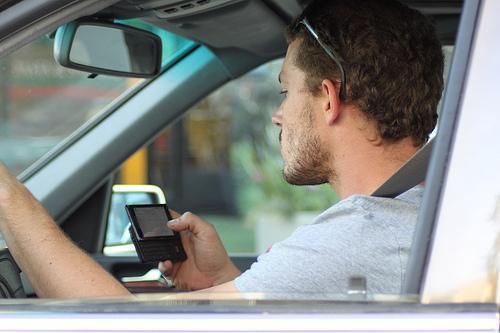How many men are there?
Give a very brief answer. 1. How many hands does the man have on the wheel?
Give a very brief answer. 1. How many mirrors are in the picture?
Give a very brief answer. 2. 